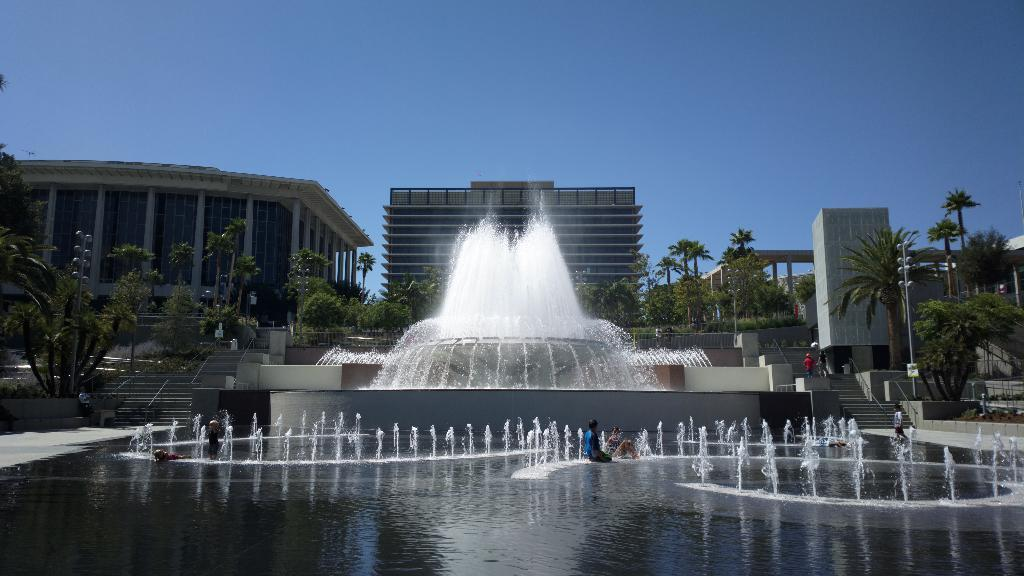How many people can be seen in the image? There are people in the image, but the exact number cannot be determined from the provided facts. What architectural feature is present in the image? There are steps and handrails visible in the image. What type of lighting is present in the image? Light poles are visible in the image. What type of vegetation is present in the image? Trees are in the image. What type of structure is present in the image? Buildings are present in the image. What type of water feature is present in the image? Water fountains are in the image. What part of the natural environment is visible in the image? The sky is visible in the image. What type of plant is burning in the image? There is no plant burning in the image; there is no mention of fire or flames in the provided facts. What type of band is performing in the image? There is no band present in the image; the provided facts do not mention any musical performance. 